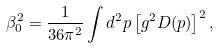<formula> <loc_0><loc_0><loc_500><loc_500>\beta _ { 0 } ^ { 2 } = \frac { 1 } { 3 6 \pi ^ { 2 } } \int d ^ { 2 } p \left [ g ^ { 2 } D ( p ) \right ] ^ { 2 } ,</formula> 